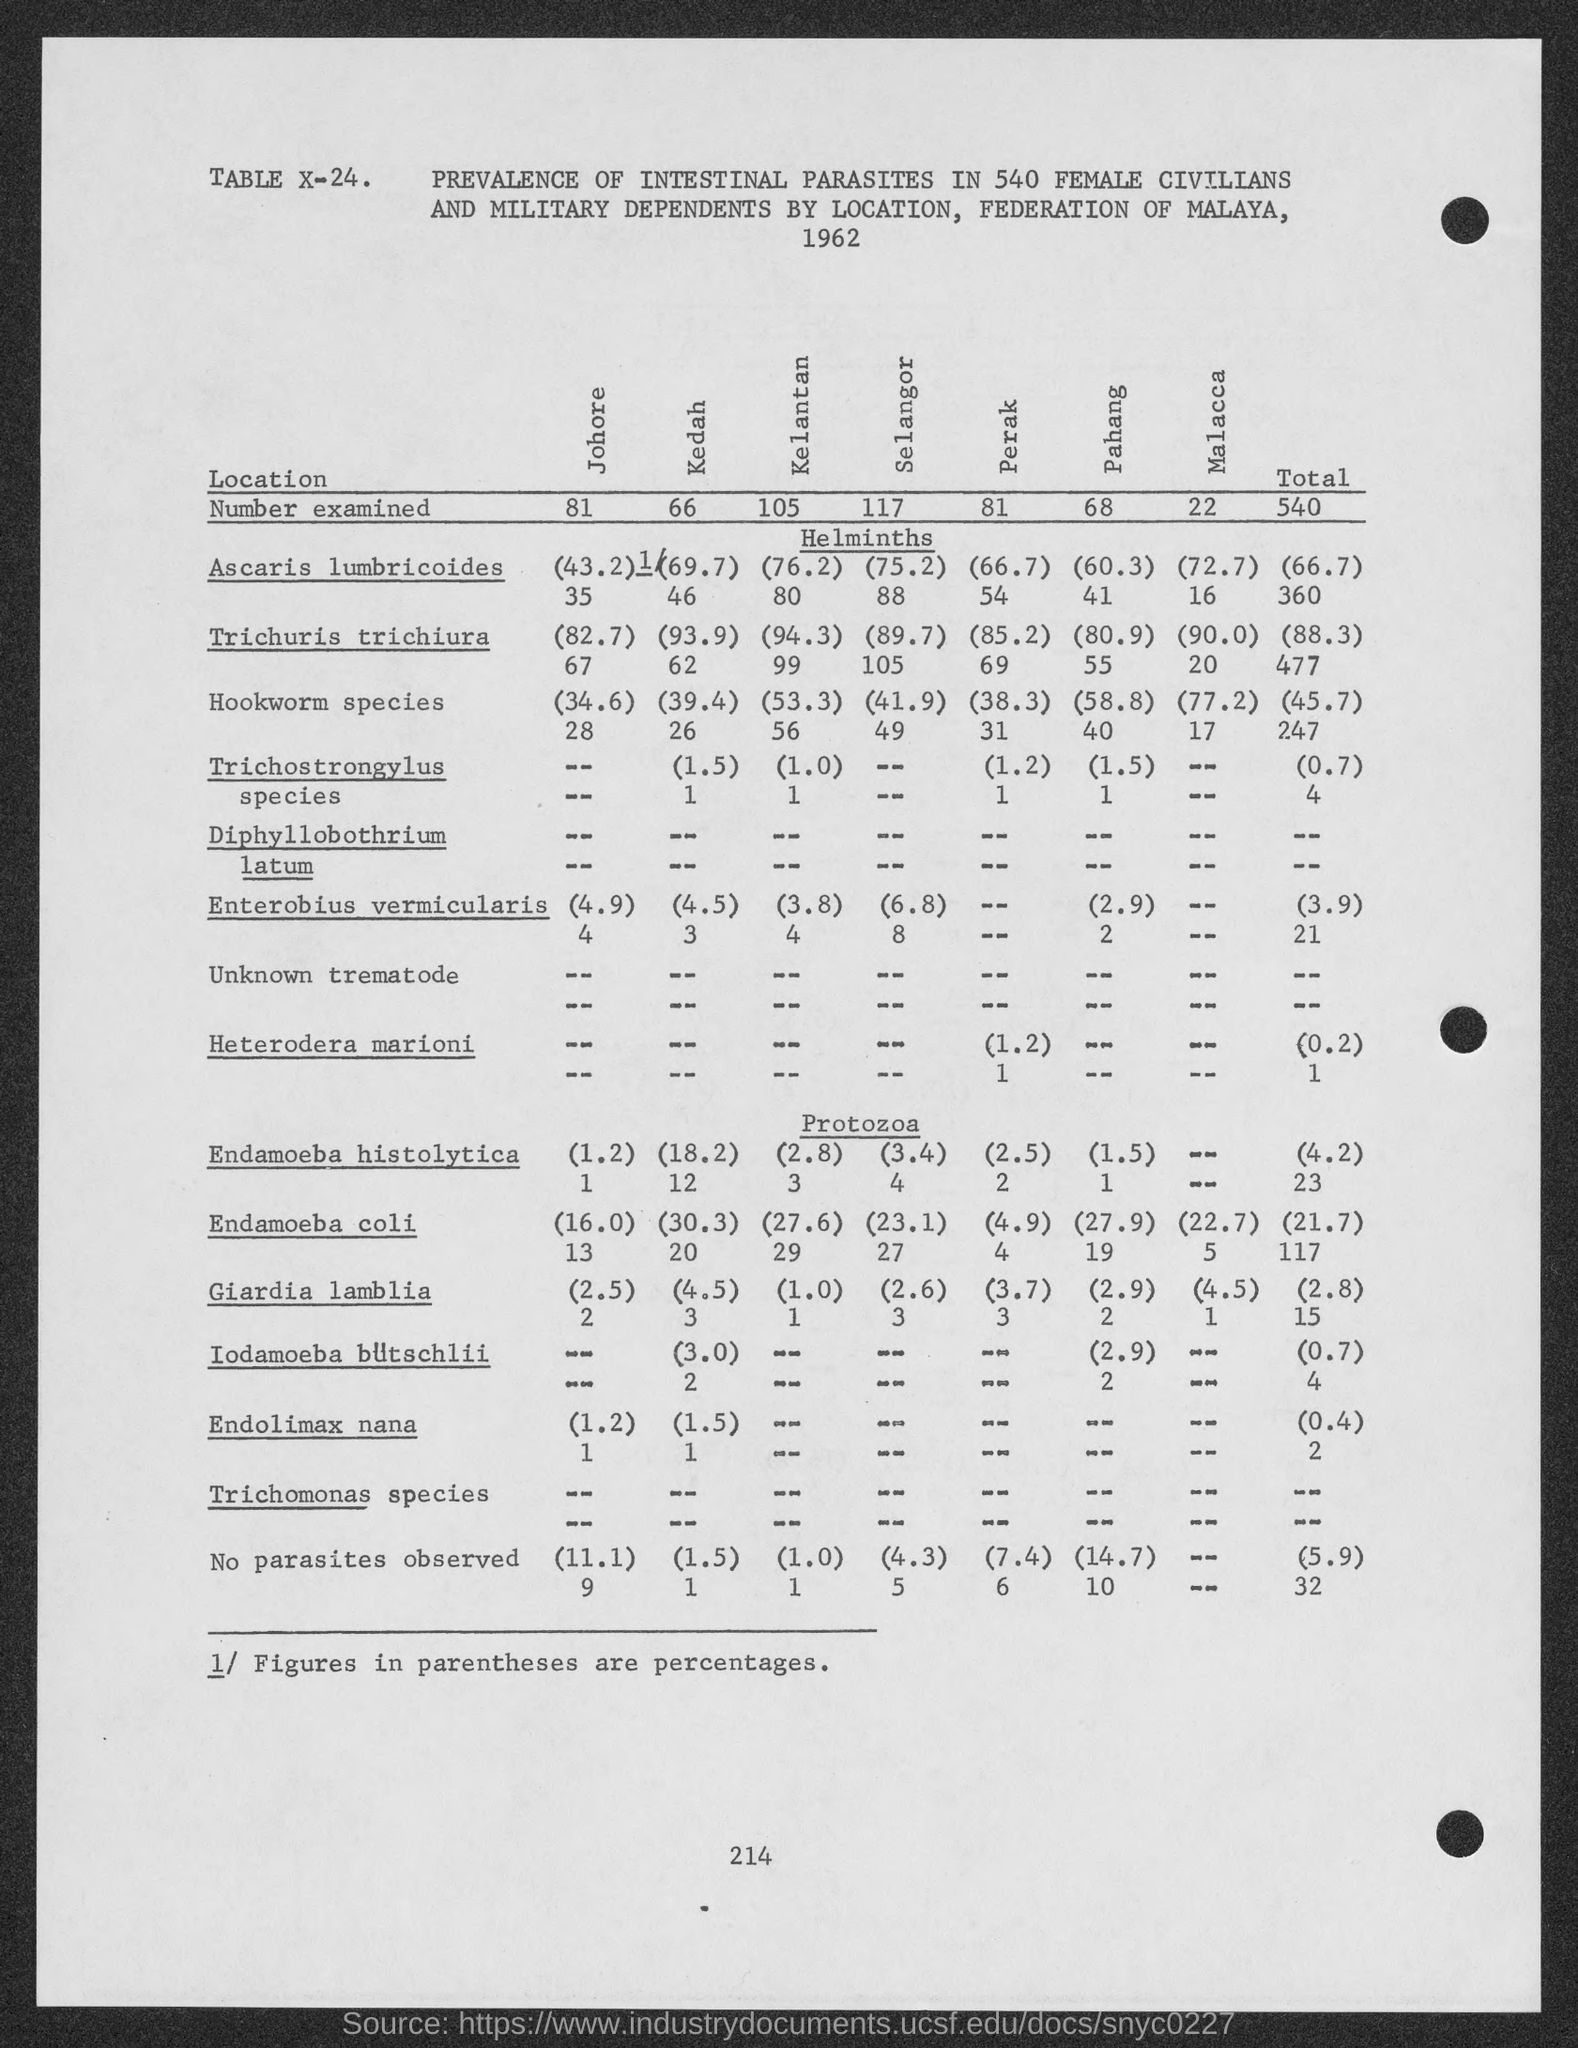What is the number at bottom of the page ?
Make the answer very short. 214. 